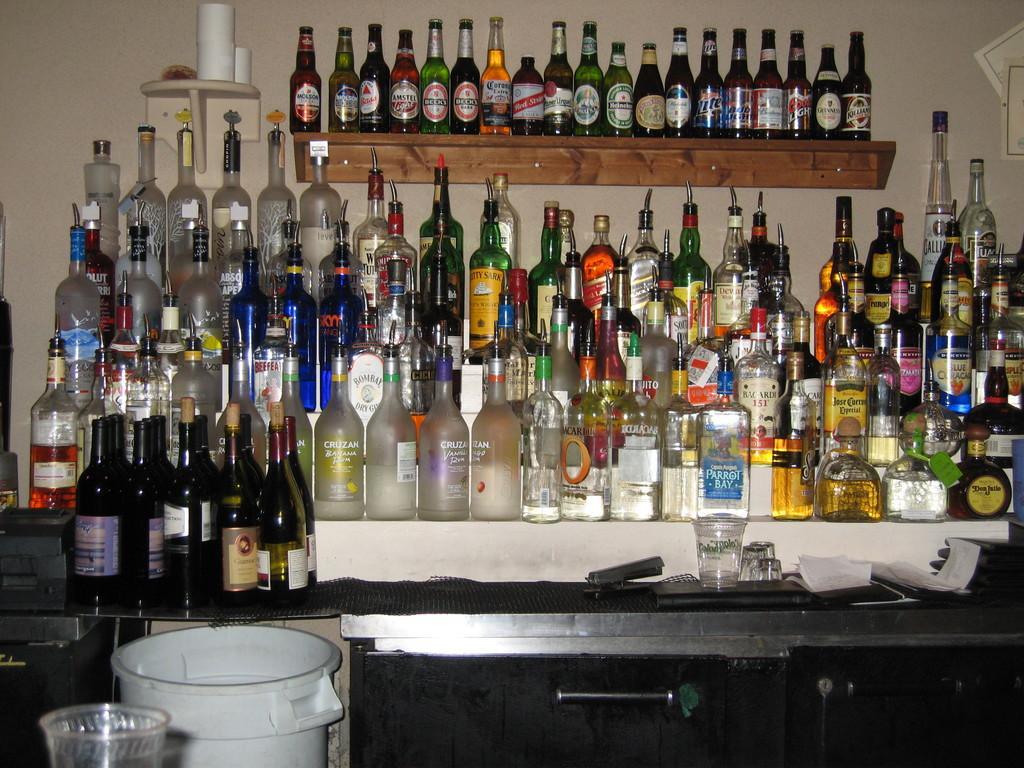Can you describe this image briefly? In the image we can see there are all wine bottles which are arranged on a table and on the rack and there is a dustbin over here. 